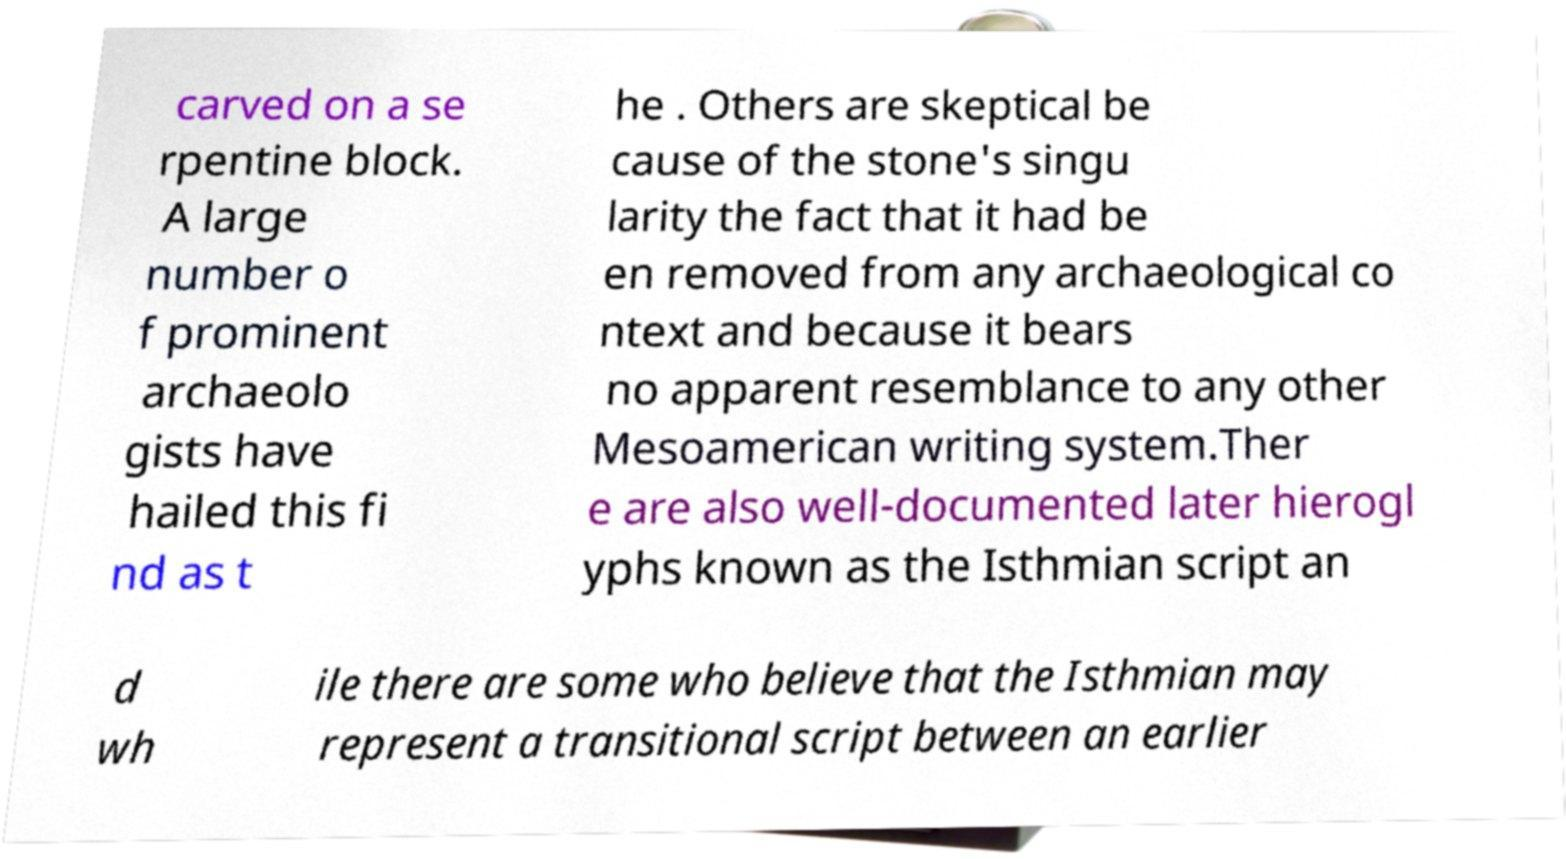For documentation purposes, I need the text within this image transcribed. Could you provide that? carved on a se rpentine block. A large number o f prominent archaeolo gists have hailed this fi nd as t he . Others are skeptical be cause of the stone's singu larity the fact that it had be en removed from any archaeological co ntext and because it bears no apparent resemblance to any other Mesoamerican writing system.Ther e are also well-documented later hierogl yphs known as the Isthmian script an d wh ile there are some who believe that the Isthmian may represent a transitional script between an earlier 